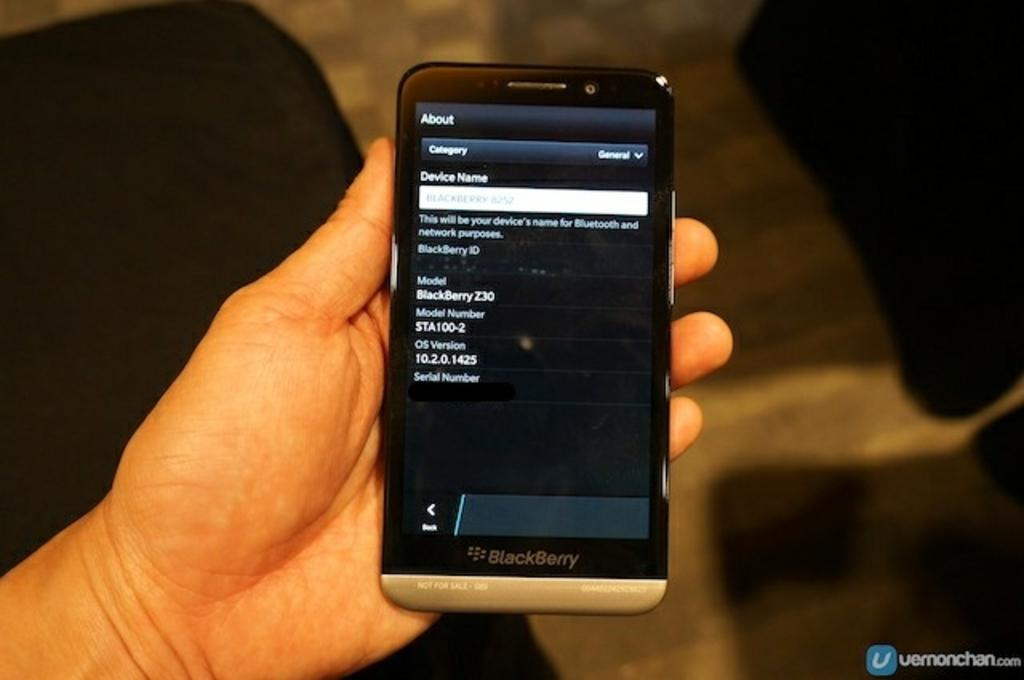Provide a one-sentence caption for the provided image. a phone that is showing the about section on it. 